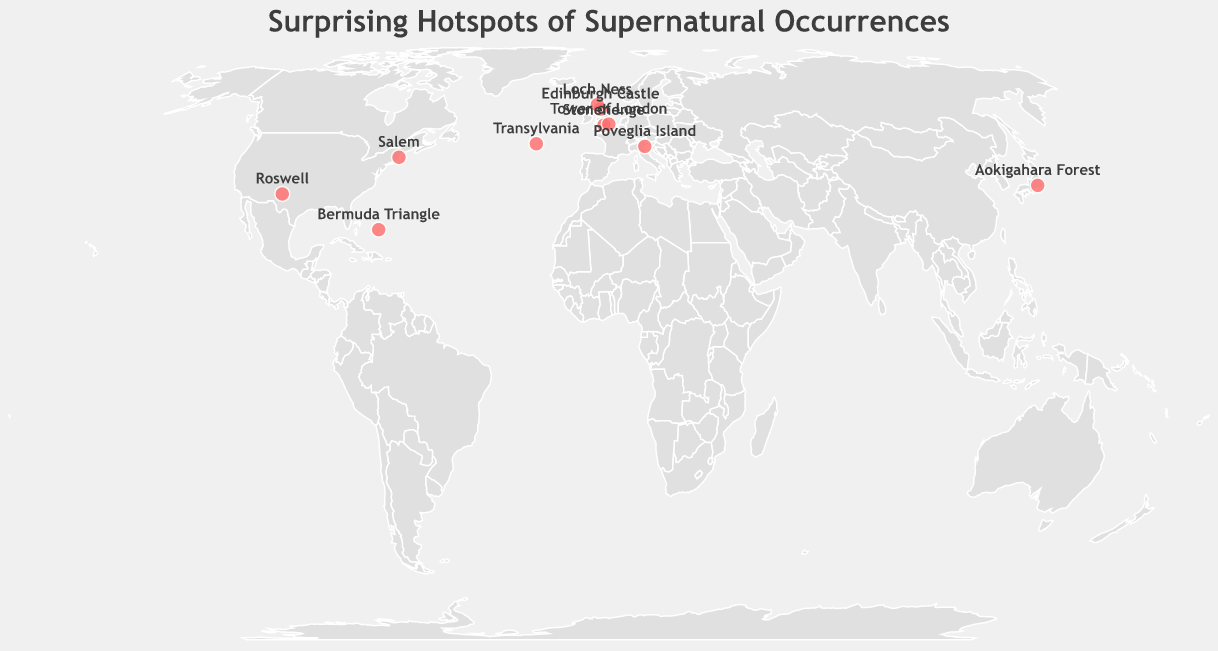What's the title of the figure? The title is usually located at the top of the figure. In this case, the title is "Surprising Hotspots of Supernatural Occurrences."
Answer: Surprising Hotspots of Supernatural Occurrences How many locations are marked with circles on the map? Each data point in the dataset appears as a circle on the map. By counting the number of circles, we see there are 10 such points.
Answer: 10 Which location has the supernatural occurrence of ghost apparitions? By looking at the tooltips or labels associated with the circles, we find that Edinburgh Castle is marked as having "Ghost apparitions."
Answer: Edinburgh Castle Are there more locations with supernatural occurrences in Europe or in North America? By counting the number of circles in each region, we note that Europe has 5 (Transylvania, Edinburgh Castle, Stonehenge, Tower of London, Poveglia Island) and North America has 3 (Salem, Loch Ness, Roswell).
Answer: Europe Which supernatural occurrence is linked with Salem, and what is the unexpected twist? Checking the tooltip or label for Salem reveals that the supernatural occurrence is "Witch activity" and the unexpected twist is "Time-traveling historians observing trials."
Answer: Witch activity; Time-traveling historians observing trials Which two locations have latitude values closest to each other? Comparing the latitude values, we find that Stonehenge (51.1789) and Tower of London (51.5081) have the closest latitude values.
Answer: Stonehenge and Tower of London Which location has the most southern latitude value? By comparing the latitude values, we find that Roswell, with a latitude of 33.3943, is the most southern.
Answer: Roswell In terms of longitude, which location is the furthest east? The location with the highest positive longitude value is Aokigahara Forest, with a longitude of 138.6742.
Answer: Aokigahara Forest What supernatural occurrence is attributed to the Bermuda Triangle and what is the unexpected twist? The tooltip indicates that the supernatural occurrence for the Bermuda Triangle is "Ship disappearances" and the unexpected twist is "Natural methane gas eruptions."
Answer: Ship disappearances; Natural methane gas eruptions 